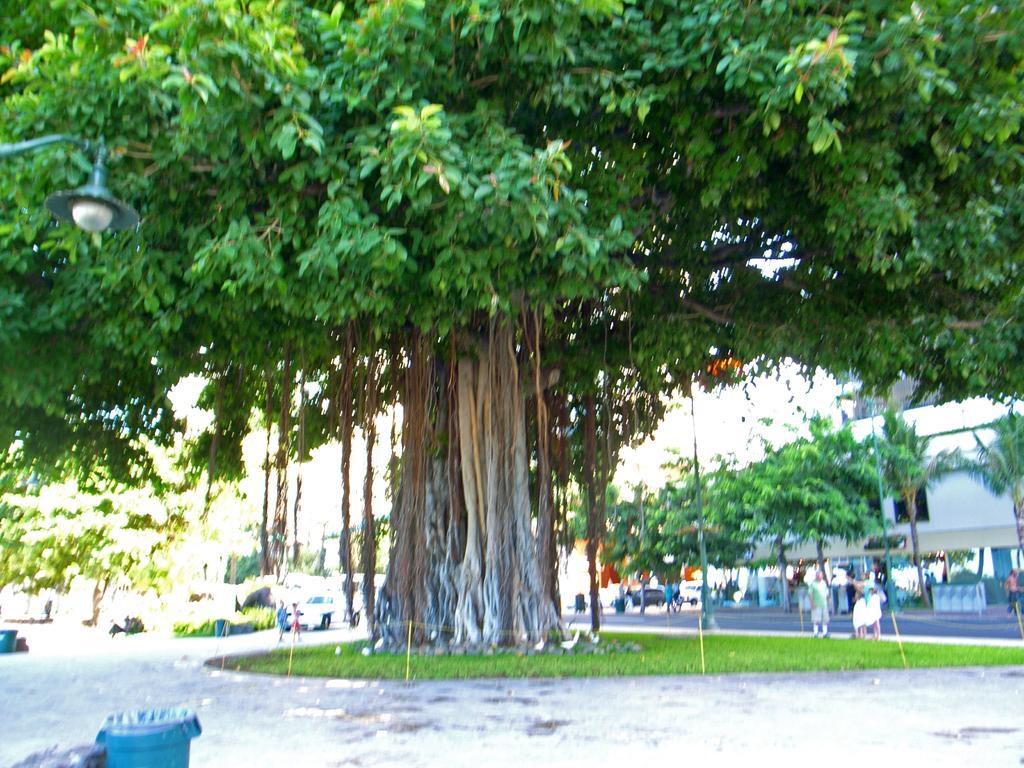Describe this image in one or two sentences. In this image we can see a tree and the grass. Behind the tree we can see the plants, vehicles, persons, poles, trees and buildings. At the bottom we can see the dustbins. On the left side, we can see a light. 